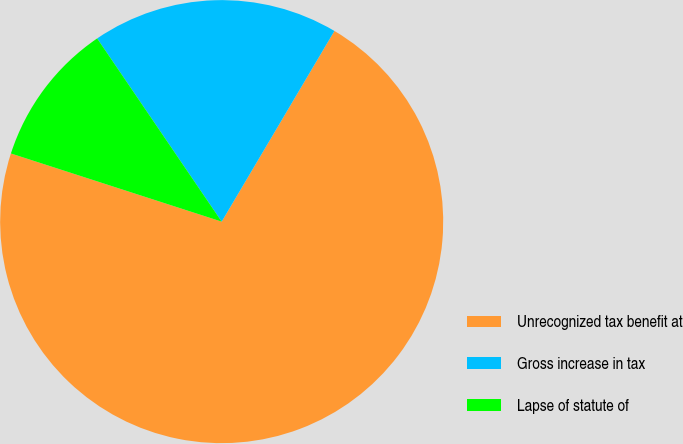Convert chart. <chart><loc_0><loc_0><loc_500><loc_500><pie_chart><fcel>Unrecognized tax benefit at<fcel>Gross increase in tax<fcel>Lapse of statute of<nl><fcel>71.48%<fcel>18.0%<fcel>10.52%<nl></chart> 